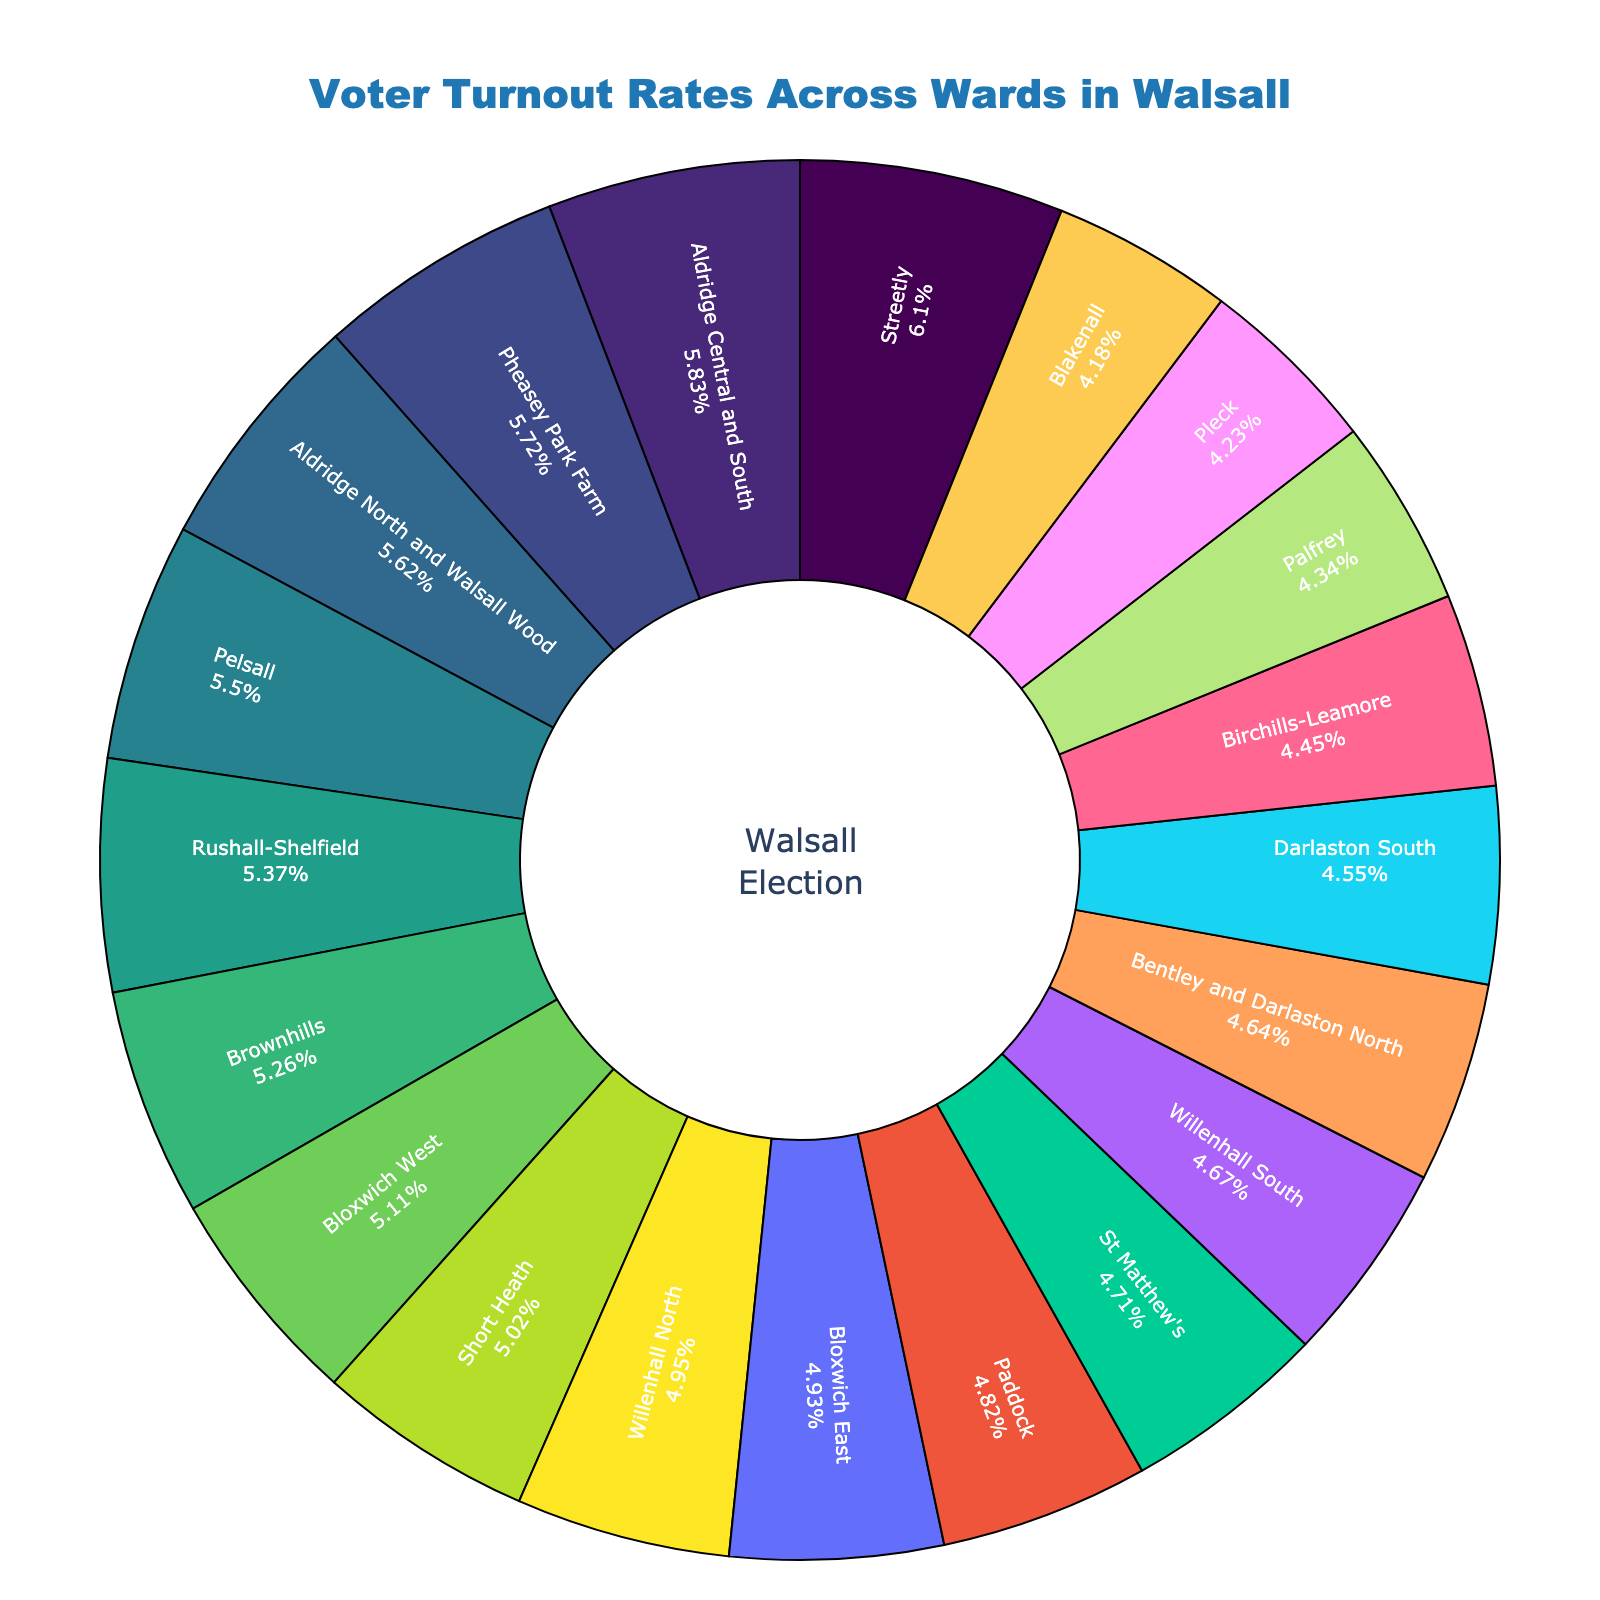Which ward has the highest voter turnout rate? Look for the largest slice in the pie chart to find the highest voter turnout rate.
Answer: Streetly Which ward has the lowest voter turnout rate? Look for the smallest slice in the pie chart to find the lowest voter turnout rate.
Answer: Blakenall What is the difference between the highest and lowest voter turnout rates? Identify the highest (Streetly, 71.3%) and lowest (Blakenall, 48.9%) voter turnout rates, and then subtract the lowest from the highest. 71.3% - 48.9% = 22.4%.
Answer: 22.4% How many wards have a voter turnout rate greater than 60%? Count the number of slices in the pie chart that represent wards with a voter turnout rate above 60%.
Answer: 7 Which wards have a voter turnout rate closest to the median value? Arrange the voter turnout rates in ascending order and find the median value. The median voter turnout rate is typically around the middle value of the sorted list.
Answer: Rushall-Shelfield (62.8%) and Brownhills (61.5%) Compare the voter turnout rates of Aldridge Central and South with Paddock. Which ward has a higher turnout rate? Identify and compare the slices corresponding to Aldridge Central and South (68.2%) and Paddock (56.4%).
Answer: Aldridge Central and South What is the average voter turnout rate across all the wards? Sum the voter turnout rates of all wards and divide by the number of wards. (68.2 + 65.7 + 54.3 + 52.1 + 48.9 + 57.6 + 59.8 + 61.5 + 53.2 + 56.4 + 50.7 + 64.3 + 66.9 + 49.5 + 62.8 + 58.7 + 55.1 + 71.3 + 57.9 + 54.6) / 20 = 59.45%.
Answer: 59.45% Identify two wards with voter turnout rates that are within 1% of each other. Look at the pie chart for slices with similar sizes, particularly checking values that are close.
Answer: Bloxwich East (57.6%) and Willenhall North (57.9%) Which wards have voter turnout rates between 50% and 60%? List the wards that have slices representing voter turnout rates within the range of 50% to 60%.
Answer: Bentley and Darlaston North, Birchills-Leamore, Blakenall, Bloxwich East, Bloxwich West, Darlaston South, Paddock, Palfrey, St Matthew's, Short Heath, Willenhall North, Willenhall South 